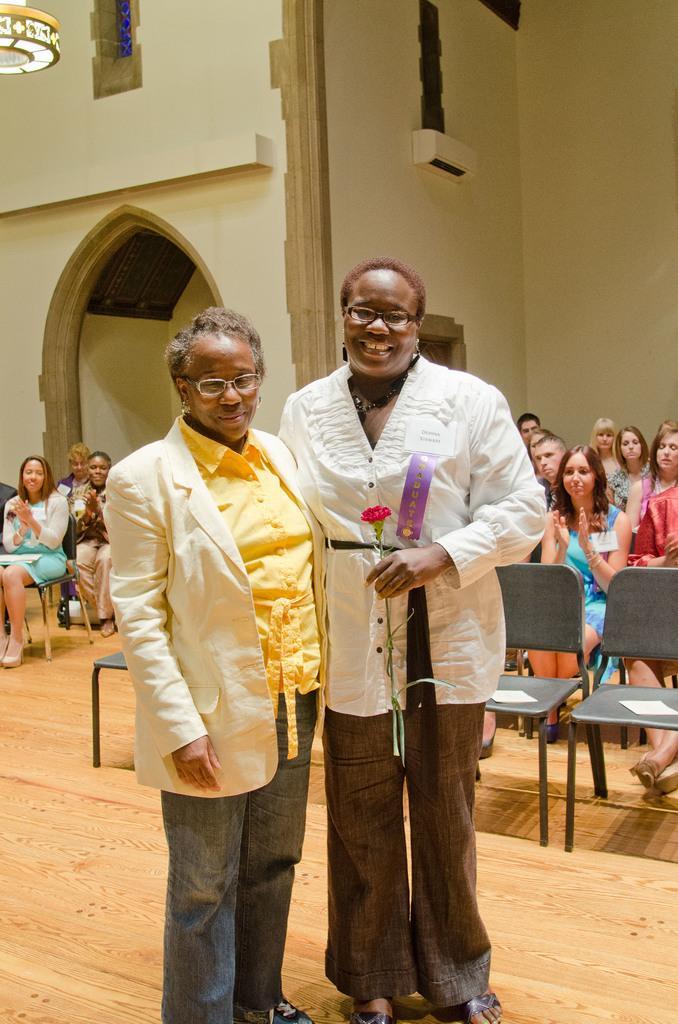Could you give a brief overview of what you see in this image? Here we can see two person see standing on the floor, and holding a rose in her hand,and at back the group of people are sitting. 